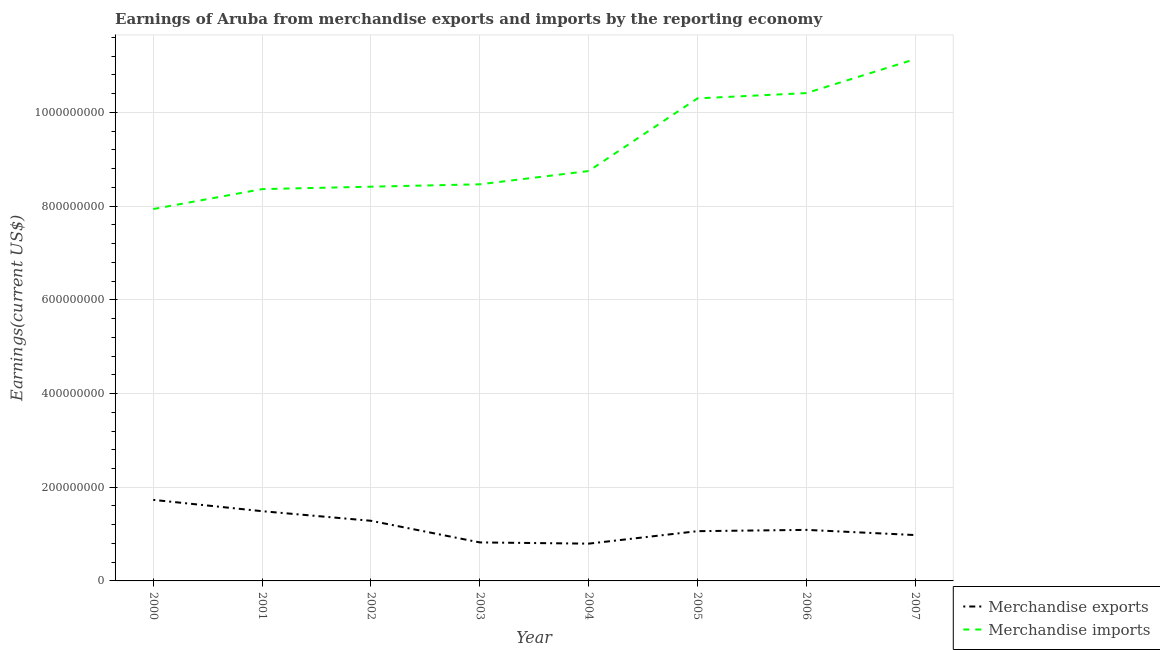What is the earnings from merchandise imports in 2007?
Offer a terse response. 1.11e+09. Across all years, what is the maximum earnings from merchandise exports?
Give a very brief answer. 1.73e+08. Across all years, what is the minimum earnings from merchandise exports?
Offer a very short reply. 7.96e+07. In which year was the earnings from merchandise exports maximum?
Offer a terse response. 2000. What is the total earnings from merchandise imports in the graph?
Offer a terse response. 7.38e+09. What is the difference between the earnings from merchandise exports in 2001 and that in 2004?
Offer a terse response. 6.93e+07. What is the difference between the earnings from merchandise exports in 2002 and the earnings from merchandise imports in 2001?
Offer a very short reply. -7.08e+08. What is the average earnings from merchandise imports per year?
Make the answer very short. 9.22e+08. In the year 2000, what is the difference between the earnings from merchandise imports and earnings from merchandise exports?
Your response must be concise. 6.21e+08. In how many years, is the earnings from merchandise exports greater than 360000000 US$?
Give a very brief answer. 0. What is the ratio of the earnings from merchandise imports in 2001 to that in 2003?
Offer a terse response. 0.99. Is the earnings from merchandise exports in 2001 less than that in 2005?
Keep it short and to the point. No. What is the difference between the highest and the second highest earnings from merchandise exports?
Make the answer very short. 2.41e+07. What is the difference between the highest and the lowest earnings from merchandise imports?
Offer a terse response. 3.20e+08. In how many years, is the earnings from merchandise imports greater than the average earnings from merchandise imports taken over all years?
Ensure brevity in your answer.  3. Is the earnings from merchandise imports strictly greater than the earnings from merchandise exports over the years?
Your answer should be compact. Yes. How many years are there in the graph?
Offer a terse response. 8. Are the values on the major ticks of Y-axis written in scientific E-notation?
Your response must be concise. No. Where does the legend appear in the graph?
Your response must be concise. Bottom right. How are the legend labels stacked?
Your response must be concise. Vertical. What is the title of the graph?
Make the answer very short. Earnings of Aruba from merchandise exports and imports by the reporting economy. Does "Not attending school" appear as one of the legend labels in the graph?
Give a very brief answer. No. What is the label or title of the Y-axis?
Offer a terse response. Earnings(current US$). What is the Earnings(current US$) in Merchandise exports in 2000?
Give a very brief answer. 1.73e+08. What is the Earnings(current US$) of Merchandise imports in 2000?
Give a very brief answer. 7.94e+08. What is the Earnings(current US$) in Merchandise exports in 2001?
Your response must be concise. 1.49e+08. What is the Earnings(current US$) of Merchandise imports in 2001?
Provide a short and direct response. 8.36e+08. What is the Earnings(current US$) of Merchandise exports in 2002?
Make the answer very short. 1.28e+08. What is the Earnings(current US$) in Merchandise imports in 2002?
Offer a terse response. 8.42e+08. What is the Earnings(current US$) in Merchandise exports in 2003?
Your answer should be compact. 8.22e+07. What is the Earnings(current US$) of Merchandise imports in 2003?
Your answer should be very brief. 8.47e+08. What is the Earnings(current US$) in Merchandise exports in 2004?
Provide a succinct answer. 7.96e+07. What is the Earnings(current US$) of Merchandise imports in 2004?
Make the answer very short. 8.75e+08. What is the Earnings(current US$) of Merchandise exports in 2005?
Make the answer very short. 1.06e+08. What is the Earnings(current US$) in Merchandise imports in 2005?
Make the answer very short. 1.03e+09. What is the Earnings(current US$) in Merchandise exports in 2006?
Offer a terse response. 1.09e+08. What is the Earnings(current US$) of Merchandise imports in 2006?
Your answer should be compact. 1.04e+09. What is the Earnings(current US$) of Merchandise exports in 2007?
Keep it short and to the point. 9.79e+07. What is the Earnings(current US$) of Merchandise imports in 2007?
Offer a very short reply. 1.11e+09. Across all years, what is the maximum Earnings(current US$) in Merchandise exports?
Make the answer very short. 1.73e+08. Across all years, what is the maximum Earnings(current US$) in Merchandise imports?
Ensure brevity in your answer.  1.11e+09. Across all years, what is the minimum Earnings(current US$) of Merchandise exports?
Your response must be concise. 7.96e+07. Across all years, what is the minimum Earnings(current US$) of Merchandise imports?
Ensure brevity in your answer.  7.94e+08. What is the total Earnings(current US$) in Merchandise exports in the graph?
Provide a short and direct response. 9.25e+08. What is the total Earnings(current US$) of Merchandise imports in the graph?
Offer a very short reply. 7.38e+09. What is the difference between the Earnings(current US$) of Merchandise exports in 2000 and that in 2001?
Make the answer very short. 2.41e+07. What is the difference between the Earnings(current US$) of Merchandise imports in 2000 and that in 2001?
Make the answer very short. -4.25e+07. What is the difference between the Earnings(current US$) in Merchandise exports in 2000 and that in 2002?
Provide a short and direct response. 4.46e+07. What is the difference between the Earnings(current US$) in Merchandise imports in 2000 and that in 2002?
Provide a succinct answer. -4.77e+07. What is the difference between the Earnings(current US$) in Merchandise exports in 2000 and that in 2003?
Offer a terse response. 9.08e+07. What is the difference between the Earnings(current US$) of Merchandise imports in 2000 and that in 2003?
Ensure brevity in your answer.  -5.28e+07. What is the difference between the Earnings(current US$) in Merchandise exports in 2000 and that in 2004?
Keep it short and to the point. 9.34e+07. What is the difference between the Earnings(current US$) in Merchandise imports in 2000 and that in 2004?
Provide a short and direct response. -8.11e+07. What is the difference between the Earnings(current US$) of Merchandise exports in 2000 and that in 2005?
Your answer should be compact. 6.68e+07. What is the difference between the Earnings(current US$) of Merchandise imports in 2000 and that in 2005?
Give a very brief answer. -2.36e+08. What is the difference between the Earnings(current US$) of Merchandise exports in 2000 and that in 2006?
Offer a very short reply. 6.40e+07. What is the difference between the Earnings(current US$) of Merchandise imports in 2000 and that in 2006?
Your answer should be compact. -2.48e+08. What is the difference between the Earnings(current US$) of Merchandise exports in 2000 and that in 2007?
Provide a short and direct response. 7.51e+07. What is the difference between the Earnings(current US$) of Merchandise imports in 2000 and that in 2007?
Offer a very short reply. -3.20e+08. What is the difference between the Earnings(current US$) of Merchandise exports in 2001 and that in 2002?
Your response must be concise. 2.05e+07. What is the difference between the Earnings(current US$) in Merchandise imports in 2001 and that in 2002?
Make the answer very short. -5.18e+06. What is the difference between the Earnings(current US$) of Merchandise exports in 2001 and that in 2003?
Provide a succinct answer. 6.67e+07. What is the difference between the Earnings(current US$) in Merchandise imports in 2001 and that in 2003?
Your answer should be compact. -1.03e+07. What is the difference between the Earnings(current US$) of Merchandise exports in 2001 and that in 2004?
Make the answer very short. 6.93e+07. What is the difference between the Earnings(current US$) of Merchandise imports in 2001 and that in 2004?
Your response must be concise. -3.86e+07. What is the difference between the Earnings(current US$) in Merchandise exports in 2001 and that in 2005?
Offer a terse response. 4.26e+07. What is the difference between the Earnings(current US$) of Merchandise imports in 2001 and that in 2005?
Keep it short and to the point. -1.94e+08. What is the difference between the Earnings(current US$) in Merchandise exports in 2001 and that in 2006?
Make the answer very short. 3.99e+07. What is the difference between the Earnings(current US$) of Merchandise imports in 2001 and that in 2006?
Provide a short and direct response. -2.05e+08. What is the difference between the Earnings(current US$) of Merchandise exports in 2001 and that in 2007?
Keep it short and to the point. 5.10e+07. What is the difference between the Earnings(current US$) of Merchandise imports in 2001 and that in 2007?
Make the answer very short. -2.78e+08. What is the difference between the Earnings(current US$) in Merchandise exports in 2002 and that in 2003?
Provide a short and direct response. 4.62e+07. What is the difference between the Earnings(current US$) in Merchandise imports in 2002 and that in 2003?
Your response must be concise. -5.08e+06. What is the difference between the Earnings(current US$) in Merchandise exports in 2002 and that in 2004?
Offer a very short reply. 4.88e+07. What is the difference between the Earnings(current US$) in Merchandise imports in 2002 and that in 2004?
Ensure brevity in your answer.  -3.34e+07. What is the difference between the Earnings(current US$) in Merchandise exports in 2002 and that in 2005?
Your response must be concise. 2.22e+07. What is the difference between the Earnings(current US$) of Merchandise imports in 2002 and that in 2005?
Keep it short and to the point. -1.89e+08. What is the difference between the Earnings(current US$) of Merchandise exports in 2002 and that in 2006?
Offer a very short reply. 1.94e+07. What is the difference between the Earnings(current US$) in Merchandise imports in 2002 and that in 2006?
Your answer should be compact. -2.00e+08. What is the difference between the Earnings(current US$) in Merchandise exports in 2002 and that in 2007?
Offer a very short reply. 3.05e+07. What is the difference between the Earnings(current US$) in Merchandise imports in 2002 and that in 2007?
Give a very brief answer. -2.72e+08. What is the difference between the Earnings(current US$) in Merchandise exports in 2003 and that in 2004?
Ensure brevity in your answer.  2.63e+06. What is the difference between the Earnings(current US$) in Merchandise imports in 2003 and that in 2004?
Your response must be concise. -2.83e+07. What is the difference between the Earnings(current US$) of Merchandise exports in 2003 and that in 2005?
Offer a terse response. -2.40e+07. What is the difference between the Earnings(current US$) in Merchandise imports in 2003 and that in 2005?
Provide a short and direct response. -1.83e+08. What is the difference between the Earnings(current US$) of Merchandise exports in 2003 and that in 2006?
Offer a very short reply. -2.68e+07. What is the difference between the Earnings(current US$) of Merchandise imports in 2003 and that in 2006?
Offer a very short reply. -1.95e+08. What is the difference between the Earnings(current US$) of Merchandise exports in 2003 and that in 2007?
Your answer should be very brief. -1.57e+07. What is the difference between the Earnings(current US$) in Merchandise imports in 2003 and that in 2007?
Your answer should be very brief. -2.67e+08. What is the difference between the Earnings(current US$) of Merchandise exports in 2004 and that in 2005?
Give a very brief answer. -2.66e+07. What is the difference between the Earnings(current US$) in Merchandise imports in 2004 and that in 2005?
Make the answer very short. -1.55e+08. What is the difference between the Earnings(current US$) in Merchandise exports in 2004 and that in 2006?
Your answer should be very brief. -2.94e+07. What is the difference between the Earnings(current US$) of Merchandise imports in 2004 and that in 2006?
Offer a very short reply. -1.66e+08. What is the difference between the Earnings(current US$) of Merchandise exports in 2004 and that in 2007?
Your answer should be very brief. -1.83e+07. What is the difference between the Earnings(current US$) of Merchandise imports in 2004 and that in 2007?
Offer a terse response. -2.39e+08. What is the difference between the Earnings(current US$) in Merchandise exports in 2005 and that in 2006?
Your answer should be compact. -2.76e+06. What is the difference between the Earnings(current US$) in Merchandise imports in 2005 and that in 2006?
Make the answer very short. -1.13e+07. What is the difference between the Earnings(current US$) in Merchandise exports in 2005 and that in 2007?
Make the answer very short. 8.31e+06. What is the difference between the Earnings(current US$) in Merchandise imports in 2005 and that in 2007?
Provide a short and direct response. -8.38e+07. What is the difference between the Earnings(current US$) in Merchandise exports in 2006 and that in 2007?
Provide a succinct answer. 1.11e+07. What is the difference between the Earnings(current US$) in Merchandise imports in 2006 and that in 2007?
Your answer should be very brief. -7.25e+07. What is the difference between the Earnings(current US$) in Merchandise exports in 2000 and the Earnings(current US$) in Merchandise imports in 2001?
Offer a terse response. -6.63e+08. What is the difference between the Earnings(current US$) of Merchandise exports in 2000 and the Earnings(current US$) of Merchandise imports in 2002?
Make the answer very short. -6.69e+08. What is the difference between the Earnings(current US$) in Merchandise exports in 2000 and the Earnings(current US$) in Merchandise imports in 2003?
Your answer should be compact. -6.74e+08. What is the difference between the Earnings(current US$) of Merchandise exports in 2000 and the Earnings(current US$) of Merchandise imports in 2004?
Offer a very short reply. -7.02e+08. What is the difference between the Earnings(current US$) of Merchandise exports in 2000 and the Earnings(current US$) of Merchandise imports in 2005?
Ensure brevity in your answer.  -8.57e+08. What is the difference between the Earnings(current US$) in Merchandise exports in 2000 and the Earnings(current US$) in Merchandise imports in 2006?
Keep it short and to the point. -8.68e+08. What is the difference between the Earnings(current US$) of Merchandise exports in 2000 and the Earnings(current US$) of Merchandise imports in 2007?
Your answer should be very brief. -9.41e+08. What is the difference between the Earnings(current US$) of Merchandise exports in 2001 and the Earnings(current US$) of Merchandise imports in 2002?
Your answer should be compact. -6.93e+08. What is the difference between the Earnings(current US$) of Merchandise exports in 2001 and the Earnings(current US$) of Merchandise imports in 2003?
Offer a very short reply. -6.98e+08. What is the difference between the Earnings(current US$) of Merchandise exports in 2001 and the Earnings(current US$) of Merchandise imports in 2004?
Your answer should be very brief. -7.26e+08. What is the difference between the Earnings(current US$) in Merchandise exports in 2001 and the Earnings(current US$) in Merchandise imports in 2005?
Provide a succinct answer. -8.81e+08. What is the difference between the Earnings(current US$) of Merchandise exports in 2001 and the Earnings(current US$) of Merchandise imports in 2006?
Give a very brief answer. -8.92e+08. What is the difference between the Earnings(current US$) in Merchandise exports in 2001 and the Earnings(current US$) in Merchandise imports in 2007?
Offer a terse response. -9.65e+08. What is the difference between the Earnings(current US$) of Merchandise exports in 2002 and the Earnings(current US$) of Merchandise imports in 2003?
Provide a succinct answer. -7.18e+08. What is the difference between the Earnings(current US$) of Merchandise exports in 2002 and the Earnings(current US$) of Merchandise imports in 2004?
Ensure brevity in your answer.  -7.47e+08. What is the difference between the Earnings(current US$) of Merchandise exports in 2002 and the Earnings(current US$) of Merchandise imports in 2005?
Provide a succinct answer. -9.02e+08. What is the difference between the Earnings(current US$) in Merchandise exports in 2002 and the Earnings(current US$) in Merchandise imports in 2006?
Keep it short and to the point. -9.13e+08. What is the difference between the Earnings(current US$) in Merchandise exports in 2002 and the Earnings(current US$) in Merchandise imports in 2007?
Your answer should be very brief. -9.86e+08. What is the difference between the Earnings(current US$) of Merchandise exports in 2003 and the Earnings(current US$) of Merchandise imports in 2004?
Make the answer very short. -7.93e+08. What is the difference between the Earnings(current US$) in Merchandise exports in 2003 and the Earnings(current US$) in Merchandise imports in 2005?
Give a very brief answer. -9.48e+08. What is the difference between the Earnings(current US$) of Merchandise exports in 2003 and the Earnings(current US$) of Merchandise imports in 2006?
Offer a very short reply. -9.59e+08. What is the difference between the Earnings(current US$) of Merchandise exports in 2003 and the Earnings(current US$) of Merchandise imports in 2007?
Your response must be concise. -1.03e+09. What is the difference between the Earnings(current US$) in Merchandise exports in 2004 and the Earnings(current US$) in Merchandise imports in 2005?
Your answer should be compact. -9.50e+08. What is the difference between the Earnings(current US$) in Merchandise exports in 2004 and the Earnings(current US$) in Merchandise imports in 2006?
Provide a short and direct response. -9.62e+08. What is the difference between the Earnings(current US$) of Merchandise exports in 2004 and the Earnings(current US$) of Merchandise imports in 2007?
Offer a very short reply. -1.03e+09. What is the difference between the Earnings(current US$) of Merchandise exports in 2005 and the Earnings(current US$) of Merchandise imports in 2006?
Ensure brevity in your answer.  -9.35e+08. What is the difference between the Earnings(current US$) in Merchandise exports in 2005 and the Earnings(current US$) in Merchandise imports in 2007?
Offer a very short reply. -1.01e+09. What is the difference between the Earnings(current US$) of Merchandise exports in 2006 and the Earnings(current US$) of Merchandise imports in 2007?
Make the answer very short. -1.00e+09. What is the average Earnings(current US$) of Merchandise exports per year?
Provide a short and direct response. 1.16e+08. What is the average Earnings(current US$) in Merchandise imports per year?
Give a very brief answer. 9.22e+08. In the year 2000, what is the difference between the Earnings(current US$) in Merchandise exports and Earnings(current US$) in Merchandise imports?
Offer a very short reply. -6.21e+08. In the year 2001, what is the difference between the Earnings(current US$) of Merchandise exports and Earnings(current US$) of Merchandise imports?
Your answer should be compact. -6.88e+08. In the year 2002, what is the difference between the Earnings(current US$) in Merchandise exports and Earnings(current US$) in Merchandise imports?
Ensure brevity in your answer.  -7.13e+08. In the year 2003, what is the difference between the Earnings(current US$) of Merchandise exports and Earnings(current US$) of Merchandise imports?
Keep it short and to the point. -7.64e+08. In the year 2004, what is the difference between the Earnings(current US$) of Merchandise exports and Earnings(current US$) of Merchandise imports?
Keep it short and to the point. -7.95e+08. In the year 2005, what is the difference between the Earnings(current US$) in Merchandise exports and Earnings(current US$) in Merchandise imports?
Ensure brevity in your answer.  -9.24e+08. In the year 2006, what is the difference between the Earnings(current US$) of Merchandise exports and Earnings(current US$) of Merchandise imports?
Keep it short and to the point. -9.32e+08. In the year 2007, what is the difference between the Earnings(current US$) in Merchandise exports and Earnings(current US$) in Merchandise imports?
Ensure brevity in your answer.  -1.02e+09. What is the ratio of the Earnings(current US$) in Merchandise exports in 2000 to that in 2001?
Provide a succinct answer. 1.16. What is the ratio of the Earnings(current US$) in Merchandise imports in 2000 to that in 2001?
Keep it short and to the point. 0.95. What is the ratio of the Earnings(current US$) of Merchandise exports in 2000 to that in 2002?
Provide a succinct answer. 1.35. What is the ratio of the Earnings(current US$) of Merchandise imports in 2000 to that in 2002?
Offer a very short reply. 0.94. What is the ratio of the Earnings(current US$) in Merchandise exports in 2000 to that in 2003?
Make the answer very short. 2.1. What is the ratio of the Earnings(current US$) in Merchandise imports in 2000 to that in 2003?
Offer a very short reply. 0.94. What is the ratio of the Earnings(current US$) in Merchandise exports in 2000 to that in 2004?
Your answer should be compact. 2.17. What is the ratio of the Earnings(current US$) of Merchandise imports in 2000 to that in 2004?
Provide a short and direct response. 0.91. What is the ratio of the Earnings(current US$) in Merchandise exports in 2000 to that in 2005?
Provide a short and direct response. 1.63. What is the ratio of the Earnings(current US$) of Merchandise imports in 2000 to that in 2005?
Your response must be concise. 0.77. What is the ratio of the Earnings(current US$) in Merchandise exports in 2000 to that in 2006?
Give a very brief answer. 1.59. What is the ratio of the Earnings(current US$) of Merchandise imports in 2000 to that in 2006?
Give a very brief answer. 0.76. What is the ratio of the Earnings(current US$) in Merchandise exports in 2000 to that in 2007?
Keep it short and to the point. 1.77. What is the ratio of the Earnings(current US$) of Merchandise imports in 2000 to that in 2007?
Provide a succinct answer. 0.71. What is the ratio of the Earnings(current US$) of Merchandise exports in 2001 to that in 2002?
Your response must be concise. 1.16. What is the ratio of the Earnings(current US$) in Merchandise imports in 2001 to that in 2002?
Your answer should be compact. 0.99. What is the ratio of the Earnings(current US$) in Merchandise exports in 2001 to that in 2003?
Provide a succinct answer. 1.81. What is the ratio of the Earnings(current US$) in Merchandise imports in 2001 to that in 2003?
Keep it short and to the point. 0.99. What is the ratio of the Earnings(current US$) in Merchandise exports in 2001 to that in 2004?
Make the answer very short. 1.87. What is the ratio of the Earnings(current US$) of Merchandise imports in 2001 to that in 2004?
Your response must be concise. 0.96. What is the ratio of the Earnings(current US$) of Merchandise exports in 2001 to that in 2005?
Ensure brevity in your answer.  1.4. What is the ratio of the Earnings(current US$) of Merchandise imports in 2001 to that in 2005?
Offer a terse response. 0.81. What is the ratio of the Earnings(current US$) of Merchandise exports in 2001 to that in 2006?
Your answer should be very brief. 1.37. What is the ratio of the Earnings(current US$) of Merchandise imports in 2001 to that in 2006?
Your answer should be compact. 0.8. What is the ratio of the Earnings(current US$) of Merchandise exports in 2001 to that in 2007?
Provide a succinct answer. 1.52. What is the ratio of the Earnings(current US$) in Merchandise imports in 2001 to that in 2007?
Your answer should be very brief. 0.75. What is the ratio of the Earnings(current US$) in Merchandise exports in 2002 to that in 2003?
Provide a succinct answer. 1.56. What is the ratio of the Earnings(current US$) in Merchandise exports in 2002 to that in 2004?
Your answer should be very brief. 1.61. What is the ratio of the Earnings(current US$) in Merchandise imports in 2002 to that in 2004?
Keep it short and to the point. 0.96. What is the ratio of the Earnings(current US$) of Merchandise exports in 2002 to that in 2005?
Provide a short and direct response. 1.21. What is the ratio of the Earnings(current US$) in Merchandise imports in 2002 to that in 2005?
Offer a terse response. 0.82. What is the ratio of the Earnings(current US$) in Merchandise exports in 2002 to that in 2006?
Ensure brevity in your answer.  1.18. What is the ratio of the Earnings(current US$) of Merchandise imports in 2002 to that in 2006?
Keep it short and to the point. 0.81. What is the ratio of the Earnings(current US$) of Merchandise exports in 2002 to that in 2007?
Keep it short and to the point. 1.31. What is the ratio of the Earnings(current US$) in Merchandise imports in 2002 to that in 2007?
Your answer should be compact. 0.76. What is the ratio of the Earnings(current US$) in Merchandise exports in 2003 to that in 2004?
Offer a terse response. 1.03. What is the ratio of the Earnings(current US$) in Merchandise imports in 2003 to that in 2004?
Your response must be concise. 0.97. What is the ratio of the Earnings(current US$) in Merchandise exports in 2003 to that in 2005?
Offer a terse response. 0.77. What is the ratio of the Earnings(current US$) of Merchandise imports in 2003 to that in 2005?
Offer a terse response. 0.82. What is the ratio of the Earnings(current US$) of Merchandise exports in 2003 to that in 2006?
Offer a very short reply. 0.75. What is the ratio of the Earnings(current US$) in Merchandise imports in 2003 to that in 2006?
Keep it short and to the point. 0.81. What is the ratio of the Earnings(current US$) in Merchandise exports in 2003 to that in 2007?
Provide a succinct answer. 0.84. What is the ratio of the Earnings(current US$) of Merchandise imports in 2003 to that in 2007?
Provide a short and direct response. 0.76. What is the ratio of the Earnings(current US$) of Merchandise exports in 2004 to that in 2005?
Offer a terse response. 0.75. What is the ratio of the Earnings(current US$) in Merchandise imports in 2004 to that in 2005?
Ensure brevity in your answer.  0.85. What is the ratio of the Earnings(current US$) in Merchandise exports in 2004 to that in 2006?
Give a very brief answer. 0.73. What is the ratio of the Earnings(current US$) of Merchandise imports in 2004 to that in 2006?
Your response must be concise. 0.84. What is the ratio of the Earnings(current US$) of Merchandise exports in 2004 to that in 2007?
Keep it short and to the point. 0.81. What is the ratio of the Earnings(current US$) in Merchandise imports in 2004 to that in 2007?
Provide a short and direct response. 0.79. What is the ratio of the Earnings(current US$) in Merchandise exports in 2005 to that in 2006?
Give a very brief answer. 0.97. What is the ratio of the Earnings(current US$) of Merchandise imports in 2005 to that in 2006?
Ensure brevity in your answer.  0.99. What is the ratio of the Earnings(current US$) of Merchandise exports in 2005 to that in 2007?
Offer a very short reply. 1.08. What is the ratio of the Earnings(current US$) in Merchandise imports in 2005 to that in 2007?
Your response must be concise. 0.92. What is the ratio of the Earnings(current US$) of Merchandise exports in 2006 to that in 2007?
Give a very brief answer. 1.11. What is the ratio of the Earnings(current US$) in Merchandise imports in 2006 to that in 2007?
Offer a terse response. 0.93. What is the difference between the highest and the second highest Earnings(current US$) of Merchandise exports?
Ensure brevity in your answer.  2.41e+07. What is the difference between the highest and the second highest Earnings(current US$) in Merchandise imports?
Provide a succinct answer. 7.25e+07. What is the difference between the highest and the lowest Earnings(current US$) in Merchandise exports?
Make the answer very short. 9.34e+07. What is the difference between the highest and the lowest Earnings(current US$) of Merchandise imports?
Provide a short and direct response. 3.20e+08. 